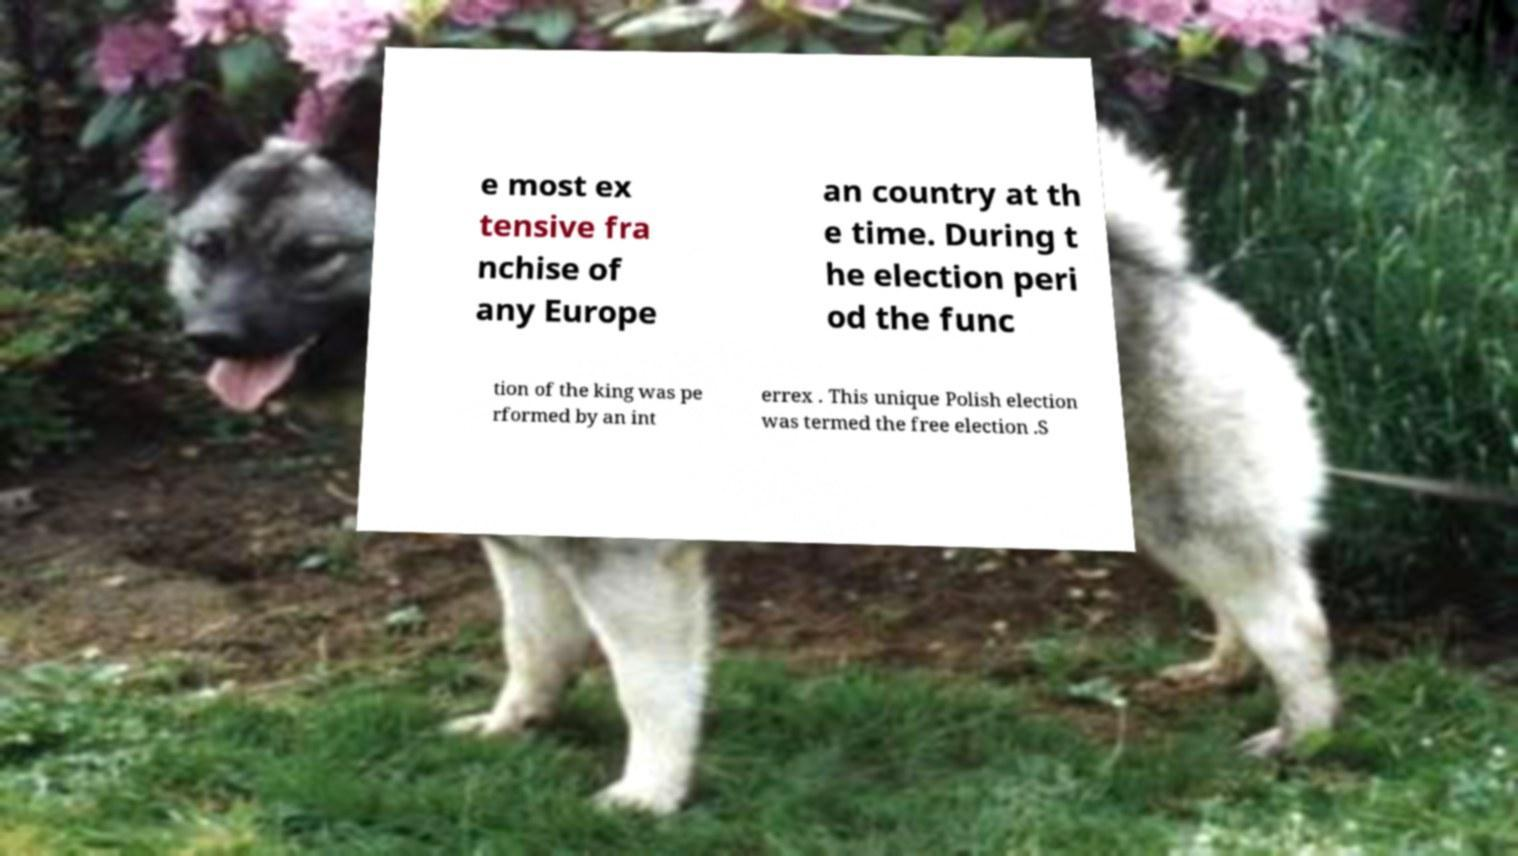For documentation purposes, I need the text within this image transcribed. Could you provide that? e most ex tensive fra nchise of any Europe an country at th e time. During t he election peri od the func tion of the king was pe rformed by an int errex . This unique Polish election was termed the free election .S 